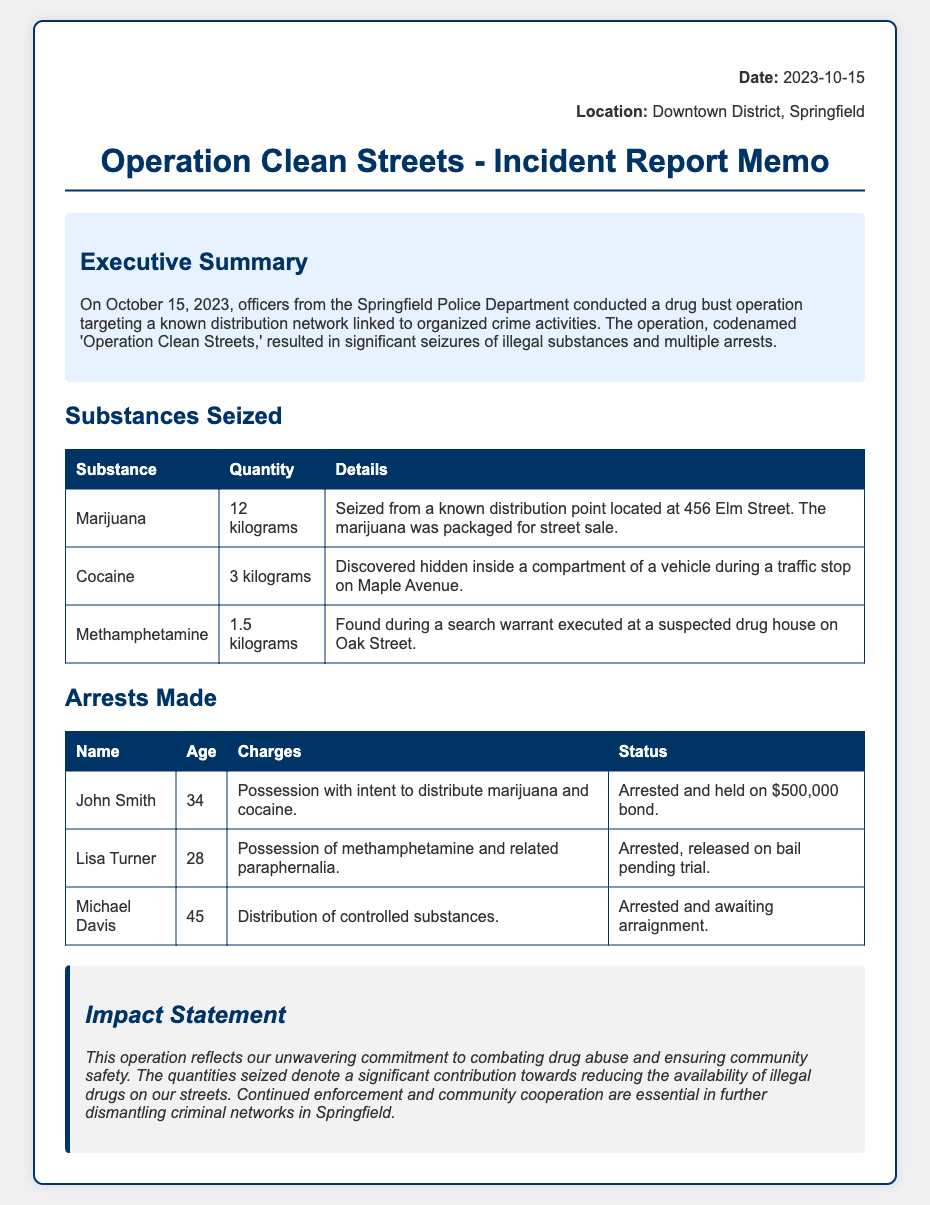what was the date of the operation? The date of the operation is stated at the beginning of the memo as October 15, 2023.
Answer: October 15, 2023 how many kilograms of marijuana were seized? The quantity of marijuana seized is specified in the table under "Substances Seized" as 12 kilograms.
Answer: 12 kilograms who was arrested for possession with intent to distribute marijuana and cocaine? The arrest table lists John Smith as the individual charged with possession with intent to distribute marijuana and cocaine.
Answer: John Smith what charge did Lisa Turner face? The charge against Lisa Turner is detailed in the arrest table as possession of methamphetamine and related paraphernalia.
Answer: Possession of methamphetamine and related paraphernalia what is the bond amount for John Smith? The bond amount for John Smith is mentioned in his arrest details as $500,000.
Answer: $500,000 how much cocaine was seized during the operation? The table shows that 3 kilograms of cocaine were seized as part of the operation.
Answer: 3 kilograms what is the impact statement’s main focus? The impact statement emphasizes the commitment to combating drug abuse and improving community safety, as highlighted in the memo.
Answer: Combating drug abuse and ensuring community safety how many arrests were made during the operation? The table lists three individuals, indicating that three arrests were made during the operation.
Answer: Three what is the name of the operation? The name of the operation is presented in the title of the memo as "Operation Clean Streets."
Answer: Operation Clean Streets 